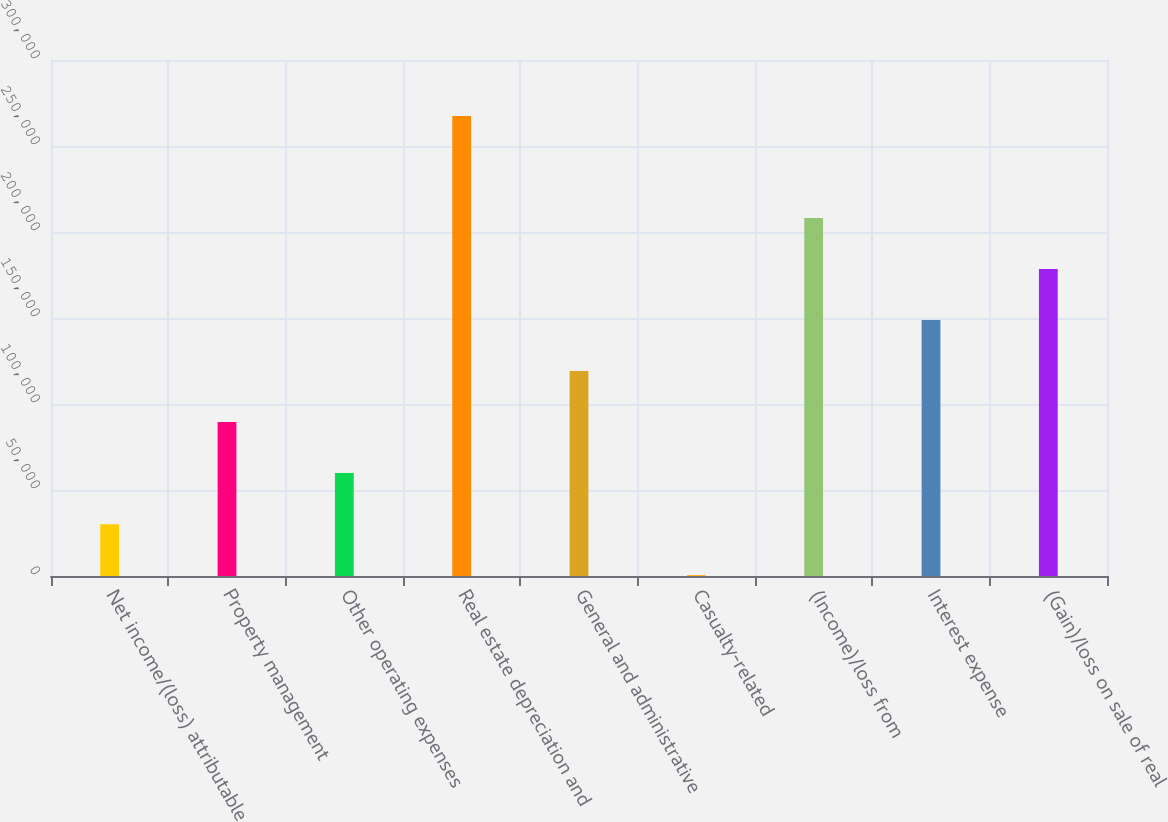Convert chart. <chart><loc_0><loc_0><loc_500><loc_500><bar_chart><fcel>Net income/(loss) attributable<fcel>Property management<fcel>Other operating expenses<fcel>Real estate depreciation and<fcel>General and administrative<fcel>Casualty-related<fcel>(Income)/loss from<fcel>Interest expense<fcel>(Gain)/loss on sale of real<nl><fcel>30147.7<fcel>89475.1<fcel>59811.4<fcel>267457<fcel>119139<fcel>484<fcel>208130<fcel>148802<fcel>178466<nl></chart> 